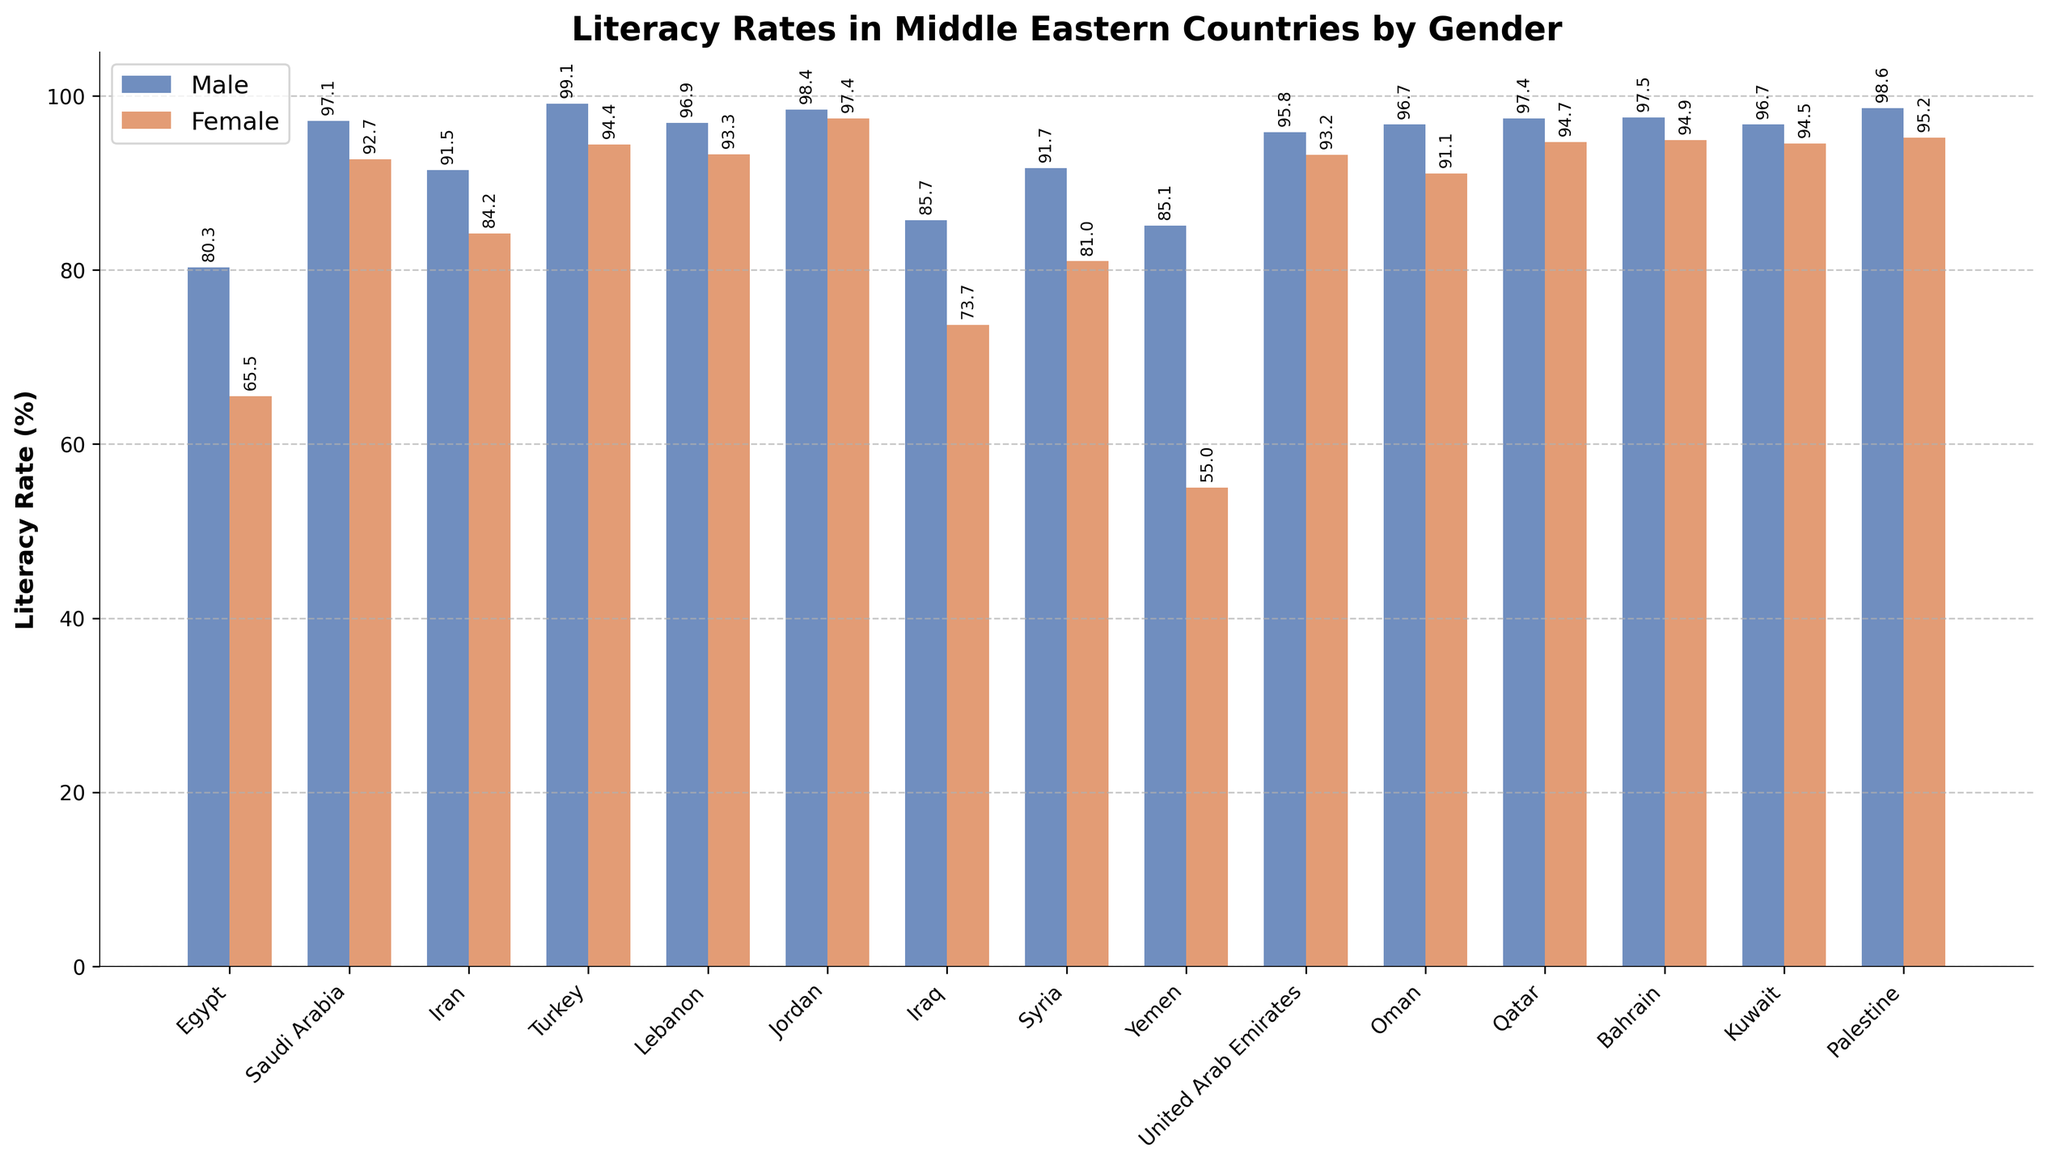Which country has the highest male literacy rate? The country with the highest male literacy rate will have the tallest blue bar among all countries. By looking at the blue bars, Turkey stands out with the highest value.
Answer: Turkey Which country shows the largest gender disparity in literacy rates? The country with the largest gender disparity will have the greatest difference between the heights of the red and blue bars. Yemen has the largest observed disparity, with a difference of 30.1 percent between male (85.1) and female (55.0) literacy rates.
Answer: Yemen What is the average female literacy rate across all countries? To calculate the average, add up all the female literacy rates and divide by the number of countries: (65.5 + 92.7 + 84.2 + 94.4 + 93.3 + 97.4 + 73.7 + 81.0 + 55.0 + 93.2 + 91.1 + 94.7 + 94.9 + 94.5 + 95.2)/15. Summing these gives 1,301.8, so the average is 1301.8/15 = 86.79.
Answer: 86.79 Which country has the smallest difference between male and female literacy rates? The country with the smallest difference will have almost identical bar heights for male and female literacy rates. Jordan's bars are the closest, with only a 1 percent difference (98.4 for males and 97.4 for females).
Answer: Jordan For which country do males have a literacy rate below 90%? Observing the blue bars, countries where the male literacy rate bars do not reach the 90% mark are Egypt, Iraq, Syria, and Yemen.
Answer: Egypt, Iraq, Syria, Yemen Compare the literacy rates of Lebanon and United Arab Emirates for both genders. Which country has higher literacy rates overall? Both the male and female literacy rates need to be compared. Lebanon has male (96.9) and female (93.3) literacy rates, while United Arab Emirates has male (95.8) and female (93.2) literacy rates. When comparing these, Lebanon has higher rates in both genders.
Answer: Lebanon Which country has the highest female literacy rate? The highest female literacy rate will be represented by the tallest red bar. Jordan stands out with the highest female literacy rate of 97.4%.
Answer: Jordan What is the difference between the male literacy rate of Qatar and the female literacy rate of Iraq? View the blue bar for Qatar and the red bar for Iraq, then calculate the difference: Qatar’s male literacy rate is 97.4, and Iraq’s female literacy rate is 73.7, so the difference is 97.4 - 73.7 = 23.7.
Answer: 23.7 How many countries have a female literacy rate above 90%? Count the number of countries where the red bar height is above the 90% mark. The countries are Saudi Arabia, Turkey, Lebanon, Jordan, United Arab Emirates, Oman, Qatar, Bahrain, Kuwait, and Palestine, totaling 10 countries.
Answer: 10 